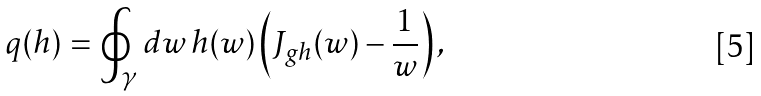<formula> <loc_0><loc_0><loc_500><loc_500>q ( h ) = \oint _ { \gamma } d w \, h ( w ) \left ( J _ { g h } ( w ) - \frac { 1 } { w } \right ) ,</formula> 